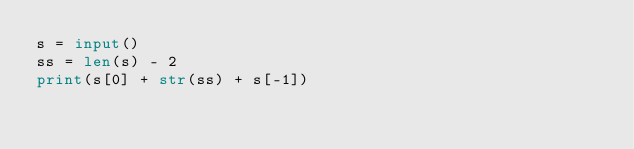<code> <loc_0><loc_0><loc_500><loc_500><_Python_>s = input()
ss = len(s) - 2
print(s[0] + str(ss) + s[-1])</code> 